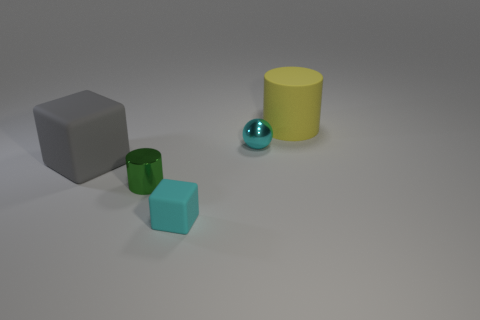What number of things are small cyan things that are in front of the tiny ball or small cyan spheres?
Your answer should be very brief. 2. The object in front of the small metallic thing in front of the block to the left of the small shiny cylinder is what shape?
Your answer should be compact. Cube. How many large gray matte things have the same shape as the tiny rubber thing?
Give a very brief answer. 1. What material is the tiny block that is the same color as the small metal ball?
Offer a terse response. Rubber. Do the small green object and the gray cube have the same material?
Provide a succinct answer. No. What number of small metallic cylinders are behind the cyan object that is behind the green metallic cylinder behind the cyan block?
Ensure brevity in your answer.  0. Is there a small ball that has the same material as the tiny cyan cube?
Ensure brevity in your answer.  No. The rubber cube that is the same color as the tiny ball is what size?
Your answer should be compact. Small. Are there fewer blue cubes than large yellow matte cylinders?
Offer a terse response. Yes. Do the cylinder that is behind the tiny cylinder and the small cube have the same color?
Provide a succinct answer. No. 